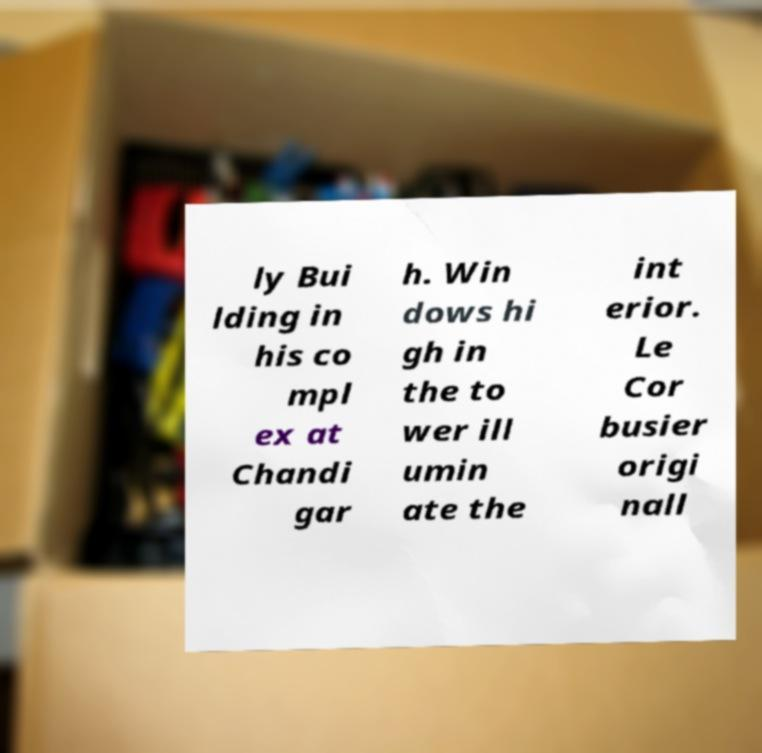There's text embedded in this image that I need extracted. Can you transcribe it verbatim? ly Bui lding in his co mpl ex at Chandi gar h. Win dows hi gh in the to wer ill umin ate the int erior. Le Cor busier origi nall 